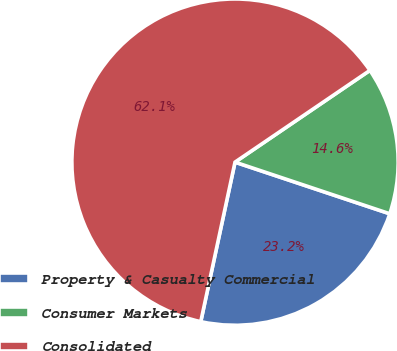Convert chart to OTSL. <chart><loc_0><loc_0><loc_500><loc_500><pie_chart><fcel>Property & Casualty Commercial<fcel>Consumer Markets<fcel>Consolidated<nl><fcel>23.24%<fcel>14.63%<fcel>62.12%<nl></chart> 